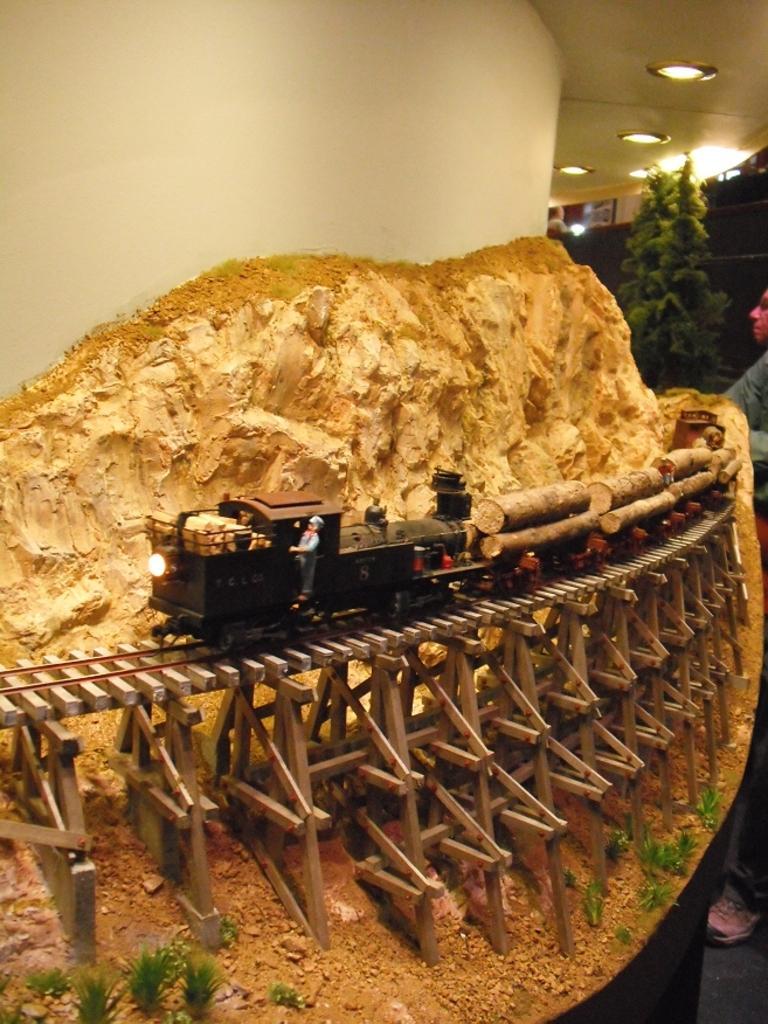Describe this image in one or two sentences. In this image we can a toy train on the bridge carrying log. We can also see some plants and the mountains which are made of sand. On the backside we can see a wall, trees, a roof with some ceiling lights and a person standing beside it. 